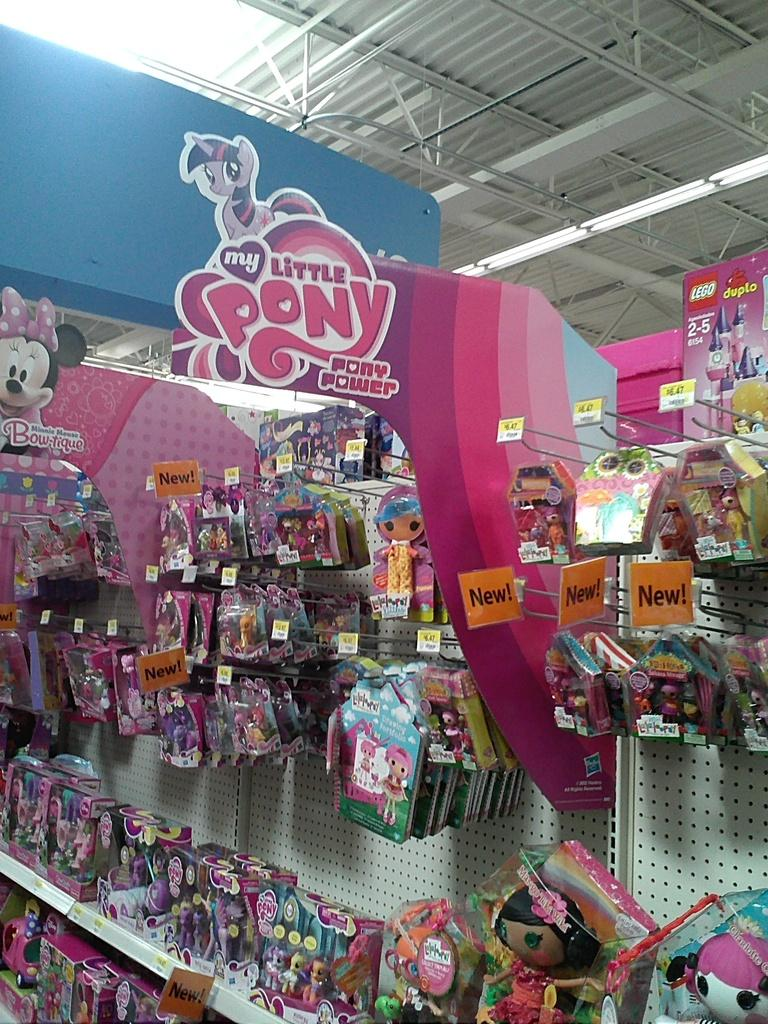What objects can be seen in the image? There are toys in the image. How are the toys protected or covered? The toys are wrapped in polythene covers. How are the toys displayed or arranged? The toys are hung on hooks. What can be seen in the background of the image? There is a shed and iron grills in the background of the image. How many chickens are sitting on the tray in the image? There are no chickens or trays present in the image. 